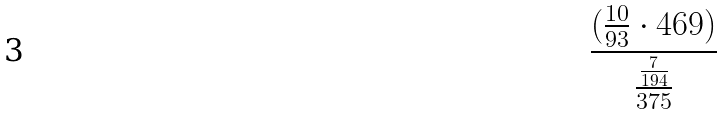Convert formula to latex. <formula><loc_0><loc_0><loc_500><loc_500>\frac { ( \frac { 1 0 } { 9 3 } \cdot 4 6 9 ) } { \frac { \frac { 7 } { 1 9 4 } } { 3 7 5 } }</formula> 